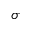<formula> <loc_0><loc_0><loc_500><loc_500>\sigma</formula> 